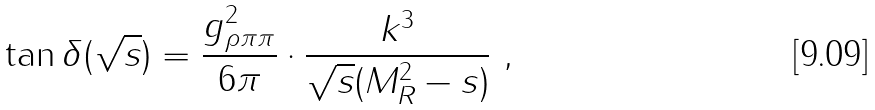<formula> <loc_0><loc_0><loc_500><loc_500>\tan \delta ( \sqrt { s } ) = \frac { g _ { \rho \pi \pi } ^ { 2 } } { 6 \pi } \cdot \frac { k ^ { 3 } } { \sqrt { s } ( M _ { R } ^ { 2 } - s ) } \ ,</formula> 